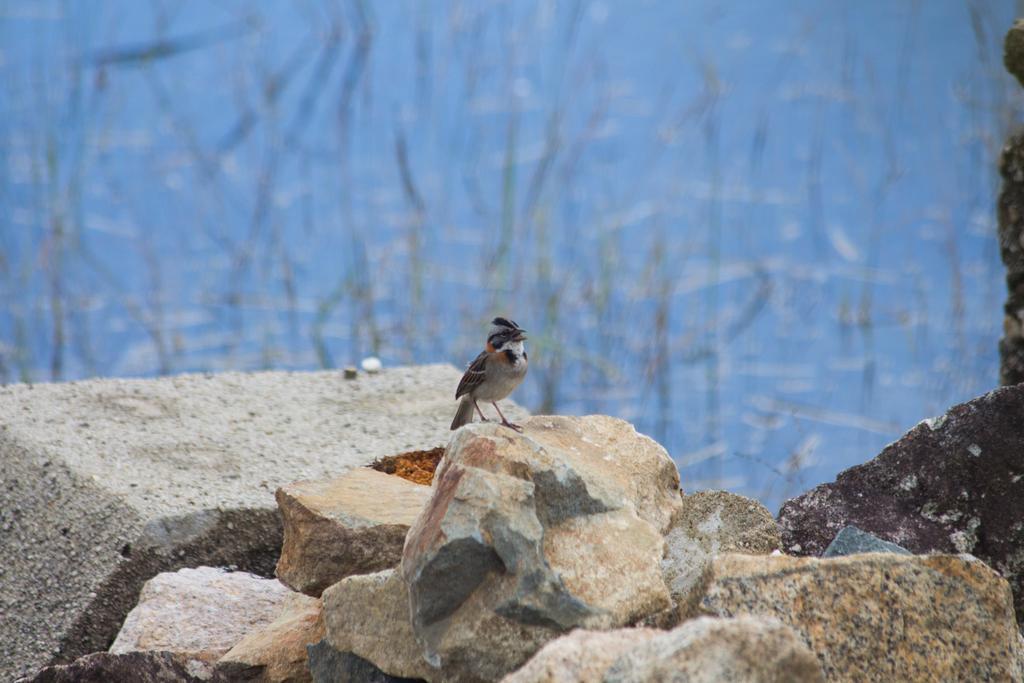Could you give a brief overview of what you see in this image? In this picture there is a bird on the stone. In the foreground there are rocks. At the back there are plants and there is water. 